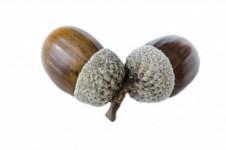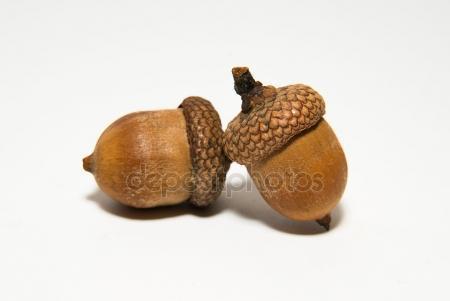The first image is the image on the left, the second image is the image on the right. For the images displayed, is the sentence "There are four acorns in total." factually correct? Answer yes or no. Yes. 